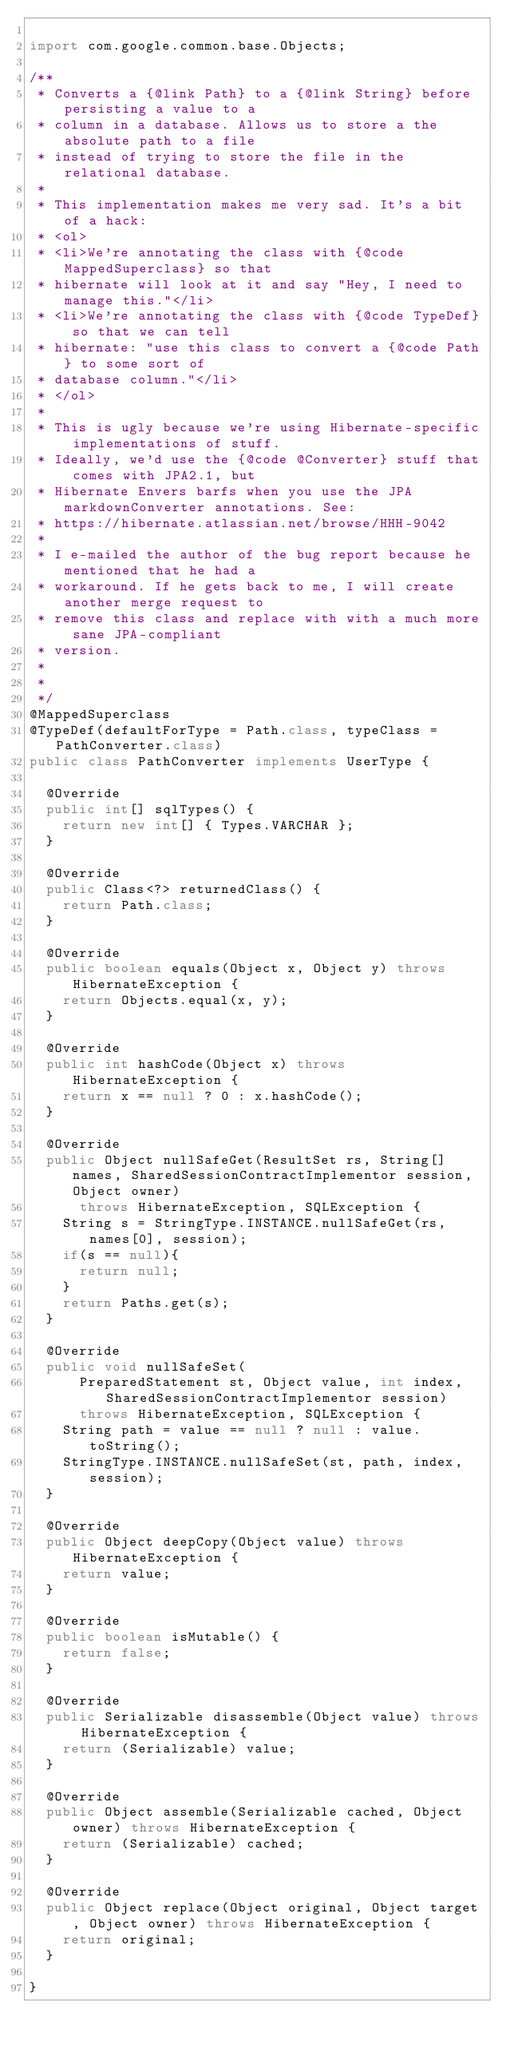<code> <loc_0><loc_0><loc_500><loc_500><_Java_>
import com.google.common.base.Objects;

/**
 * Converts a {@link Path} to a {@link String} before persisting a value to a
 * column in a database. Allows us to store a the absolute path to a file
 * instead of trying to store the file in the relational database.
 * 
 * This implementation makes me very sad. It's a bit of a hack:
 * <ol>
 * <li>We're annotating the class with {@code MappedSuperclass} so that
 * hibernate will look at it and say "Hey, I need to manage this."</li>
 * <li>We're annotating the class with {@code TypeDef} so that we can tell
 * hibernate: "use this class to convert a {@code Path} to some sort of
 * database column."</li>
 * </ol>
 *
 * This is ugly because we're using Hibernate-specific implementations of stuff.
 * Ideally, we'd use the {@code @Converter} stuff that comes with JPA2.1, but
 * Hibernate Envers barfs when you use the JPA markdownConverter annotations. See:
 * https://hibernate.atlassian.net/browse/HHH-9042
 *
 * I e-mailed the author of the bug report because he mentioned that he had a
 * workaround. If he gets back to me, I will create another merge request to
 * remove this class and replace with with a much more sane JPA-compliant
 * version.
 *
 *
 */
@MappedSuperclass
@TypeDef(defaultForType = Path.class, typeClass = PathConverter.class)
public class PathConverter implements UserType {

	@Override
	public int[] sqlTypes() {
		return new int[] { Types.VARCHAR };
	}

	@Override
	public Class<?> returnedClass() {
		return Path.class;
	}

	@Override
	public boolean equals(Object x, Object y) throws HibernateException {
		return Objects.equal(x, y);
	}

	@Override
	public int hashCode(Object x) throws HibernateException {
		return x == null ? 0 : x.hashCode();
	}

	@Override
	public Object nullSafeGet(ResultSet rs, String[] names, SharedSessionContractImplementor session, Object owner)
			throws HibernateException, SQLException {
		String s = StringType.INSTANCE.nullSafeGet(rs, names[0], session);
		if(s == null){
			return null;
		}
		return Paths.get(s);
	}

	@Override
	public void nullSafeSet(
			PreparedStatement st, Object value, int index, SharedSessionContractImplementor session)
			throws HibernateException, SQLException {
		String path = value == null ? null : value.toString();
		StringType.INSTANCE.nullSafeSet(st, path, index, session);
	}

	@Override
	public Object deepCopy(Object value) throws HibernateException {
		return value;
	}

	@Override
	public boolean isMutable() {
		return false;
	}

	@Override
	public Serializable disassemble(Object value) throws HibernateException {
		return (Serializable) value;
	}

	@Override
	public Object assemble(Serializable cached, Object owner) throws HibernateException {
		return (Serializable) cached;
	}

	@Override
	public Object replace(Object original, Object target, Object owner) throws HibernateException {
		return original;
	}

}
</code> 